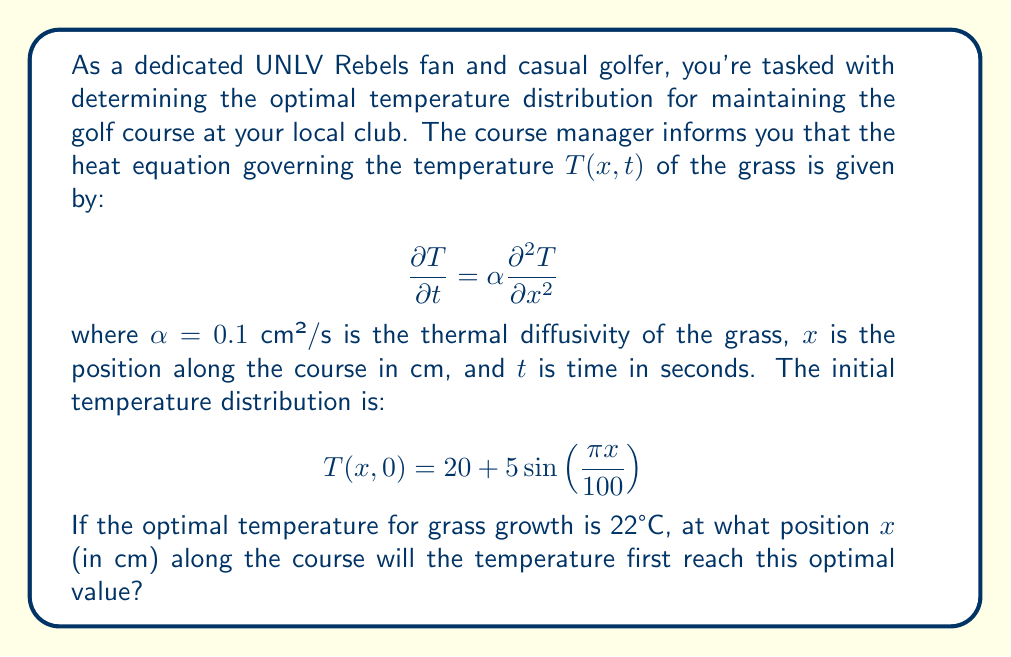Can you answer this question? To solve this problem, we need to follow these steps:

1) The initial temperature distribution is given by:
   $$T(x,0) = 20 + 5\sin(\frac{\pi x}{100})$$

2) We need to find the position $x$ where this temperature equals 22°C:
   $$22 = 20 + 5\sin(\frac{\pi x}{100})$$

3) Solve for $\sin(\frac{\pi x}{100})$:
   $$2 = 5\sin(\frac{\pi x}{100})$$
   $$\frac{2}{5} = \sin(\frac{\pi x}{100})$$

4) Take the arcsine of both sides:
   $$\arcsin(\frac{2}{5}) = \frac{\pi x}{100}$$

5) Solve for $x$:
   $$x = \frac{100}{\pi} \arcsin(\frac{2}{5})$$

6) Calculate the value (you can use a calculator for this):
   $$x \approx 23.6 \text{ cm}$$

The temperature will also reach 22°C at $100 - 23.6 = 76.4$ cm due to the symmetry of the sine function, but we're asked for the first position where this occurs.
Answer: 23.6 cm 